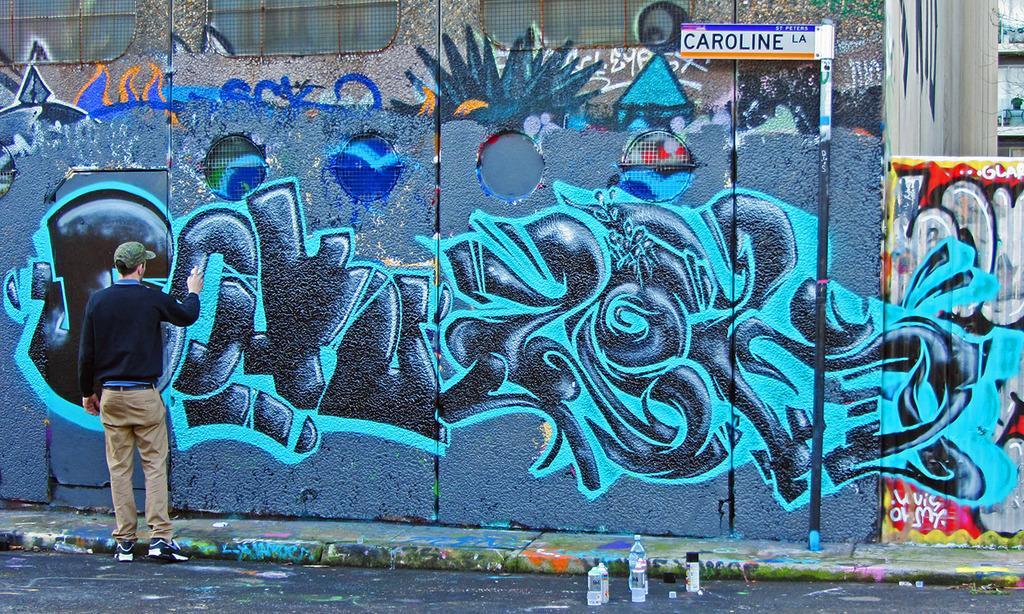In one or two sentences, can you explain what this image depicts? There is a person standing and holding bottle. We can see graffiti on wall and we can see board on pole. We can see bottles on surface. 